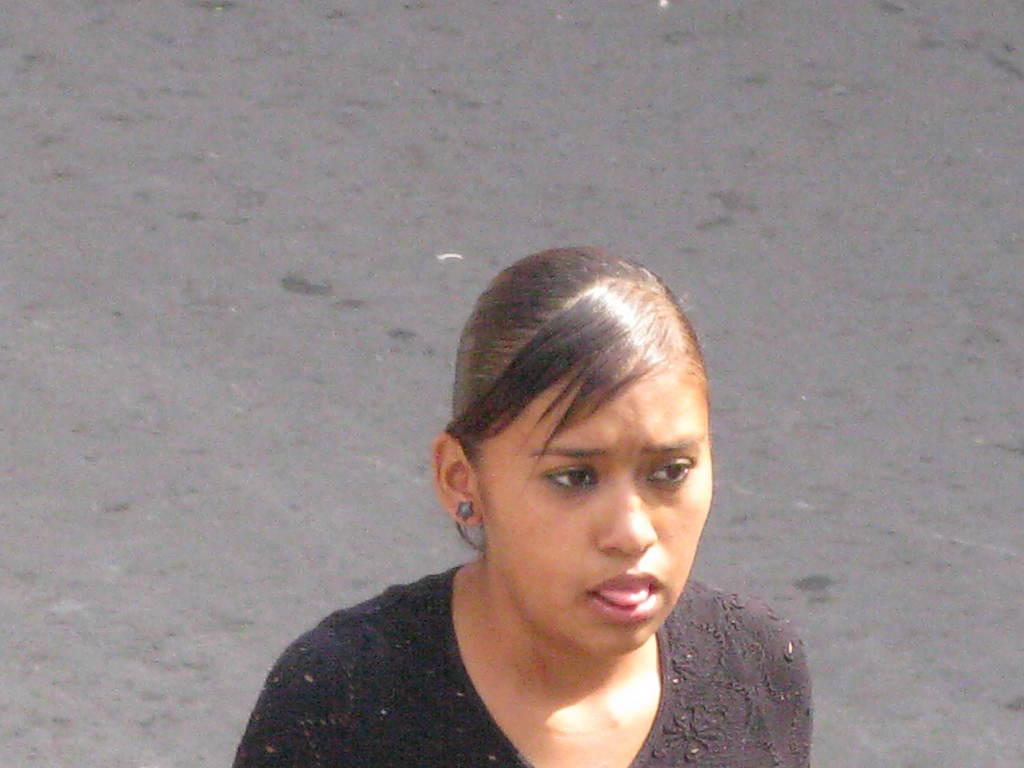What is the main subject of the image? The main subject of the image is a woman. What can be seen in the background of the image? There is a road visible in the background of the image. What type of egg is being used in the apparatus in the image? There is no egg or apparatus present in the image. What point is the woman trying to make in the image? The image does not provide any context or information about the woman's intentions or the point she might be trying to make. 